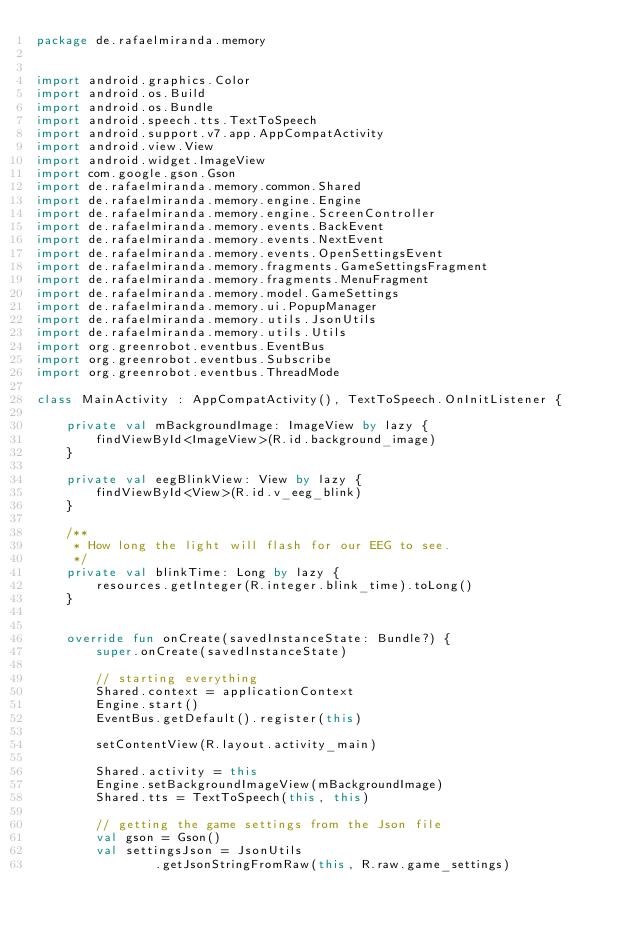Convert code to text. <code><loc_0><loc_0><loc_500><loc_500><_Kotlin_>package de.rafaelmiranda.memory


import android.graphics.Color
import android.os.Build
import android.os.Bundle
import android.speech.tts.TextToSpeech
import android.support.v7.app.AppCompatActivity
import android.view.View
import android.widget.ImageView
import com.google.gson.Gson
import de.rafaelmiranda.memory.common.Shared
import de.rafaelmiranda.memory.engine.Engine
import de.rafaelmiranda.memory.engine.ScreenController
import de.rafaelmiranda.memory.events.BackEvent
import de.rafaelmiranda.memory.events.NextEvent
import de.rafaelmiranda.memory.events.OpenSettingsEvent
import de.rafaelmiranda.memory.fragments.GameSettingsFragment
import de.rafaelmiranda.memory.fragments.MenuFragment
import de.rafaelmiranda.memory.model.GameSettings
import de.rafaelmiranda.memory.ui.PopupManager
import de.rafaelmiranda.memory.utils.JsonUtils
import de.rafaelmiranda.memory.utils.Utils
import org.greenrobot.eventbus.EventBus
import org.greenrobot.eventbus.Subscribe
import org.greenrobot.eventbus.ThreadMode

class MainActivity : AppCompatActivity(), TextToSpeech.OnInitListener {

    private val mBackgroundImage: ImageView by lazy {
        findViewById<ImageView>(R.id.background_image)
    }

    private val eegBlinkView: View by lazy {
        findViewById<View>(R.id.v_eeg_blink)
    }

    /**
     * How long the light will flash for our EEG to see.
     */
    private val blinkTime: Long by lazy {
        resources.getInteger(R.integer.blink_time).toLong()
    }


    override fun onCreate(savedInstanceState: Bundle?) {
        super.onCreate(savedInstanceState)

        // starting everything
        Shared.context = applicationContext
        Engine.start()
        EventBus.getDefault().register(this)

        setContentView(R.layout.activity_main)

        Shared.activity = this
        Engine.setBackgroundImageView(mBackgroundImage)
        Shared.tts = TextToSpeech(this, this)

        // getting the game settings from the Json file
        val gson = Gson()
        val settingsJson = JsonUtils
                .getJsonStringFromRaw(this, R.raw.game_settings)</code> 